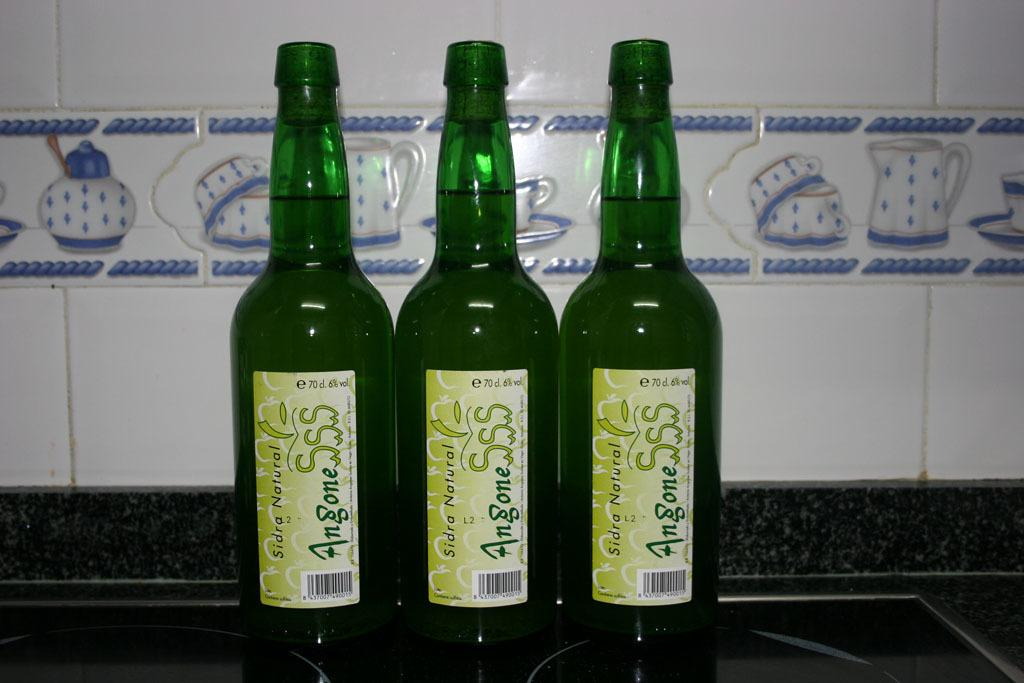How many bottles are visible in the image? There are three green bottles in the image. What is inside the bottles? The bottles contain liquid. Where are the bottles located? The bottles are placed on a table. What type of instrument is being played by the bears on the branch in the image? There are no bears or instruments present in the image; it only features three green bottles on a table. 